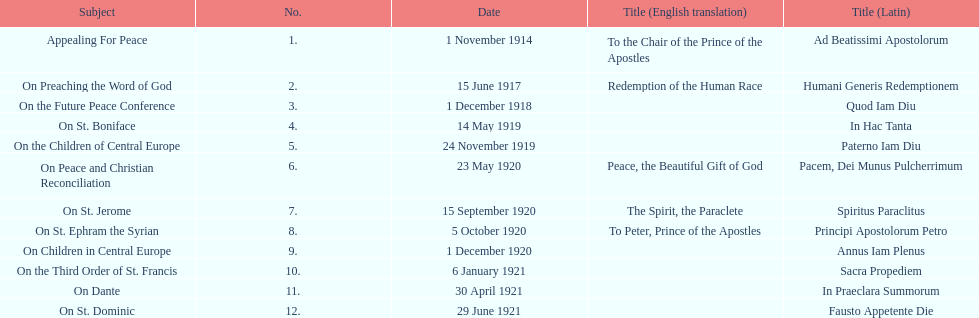What is the next title listed after sacra propediem? In Praeclara Summorum. 